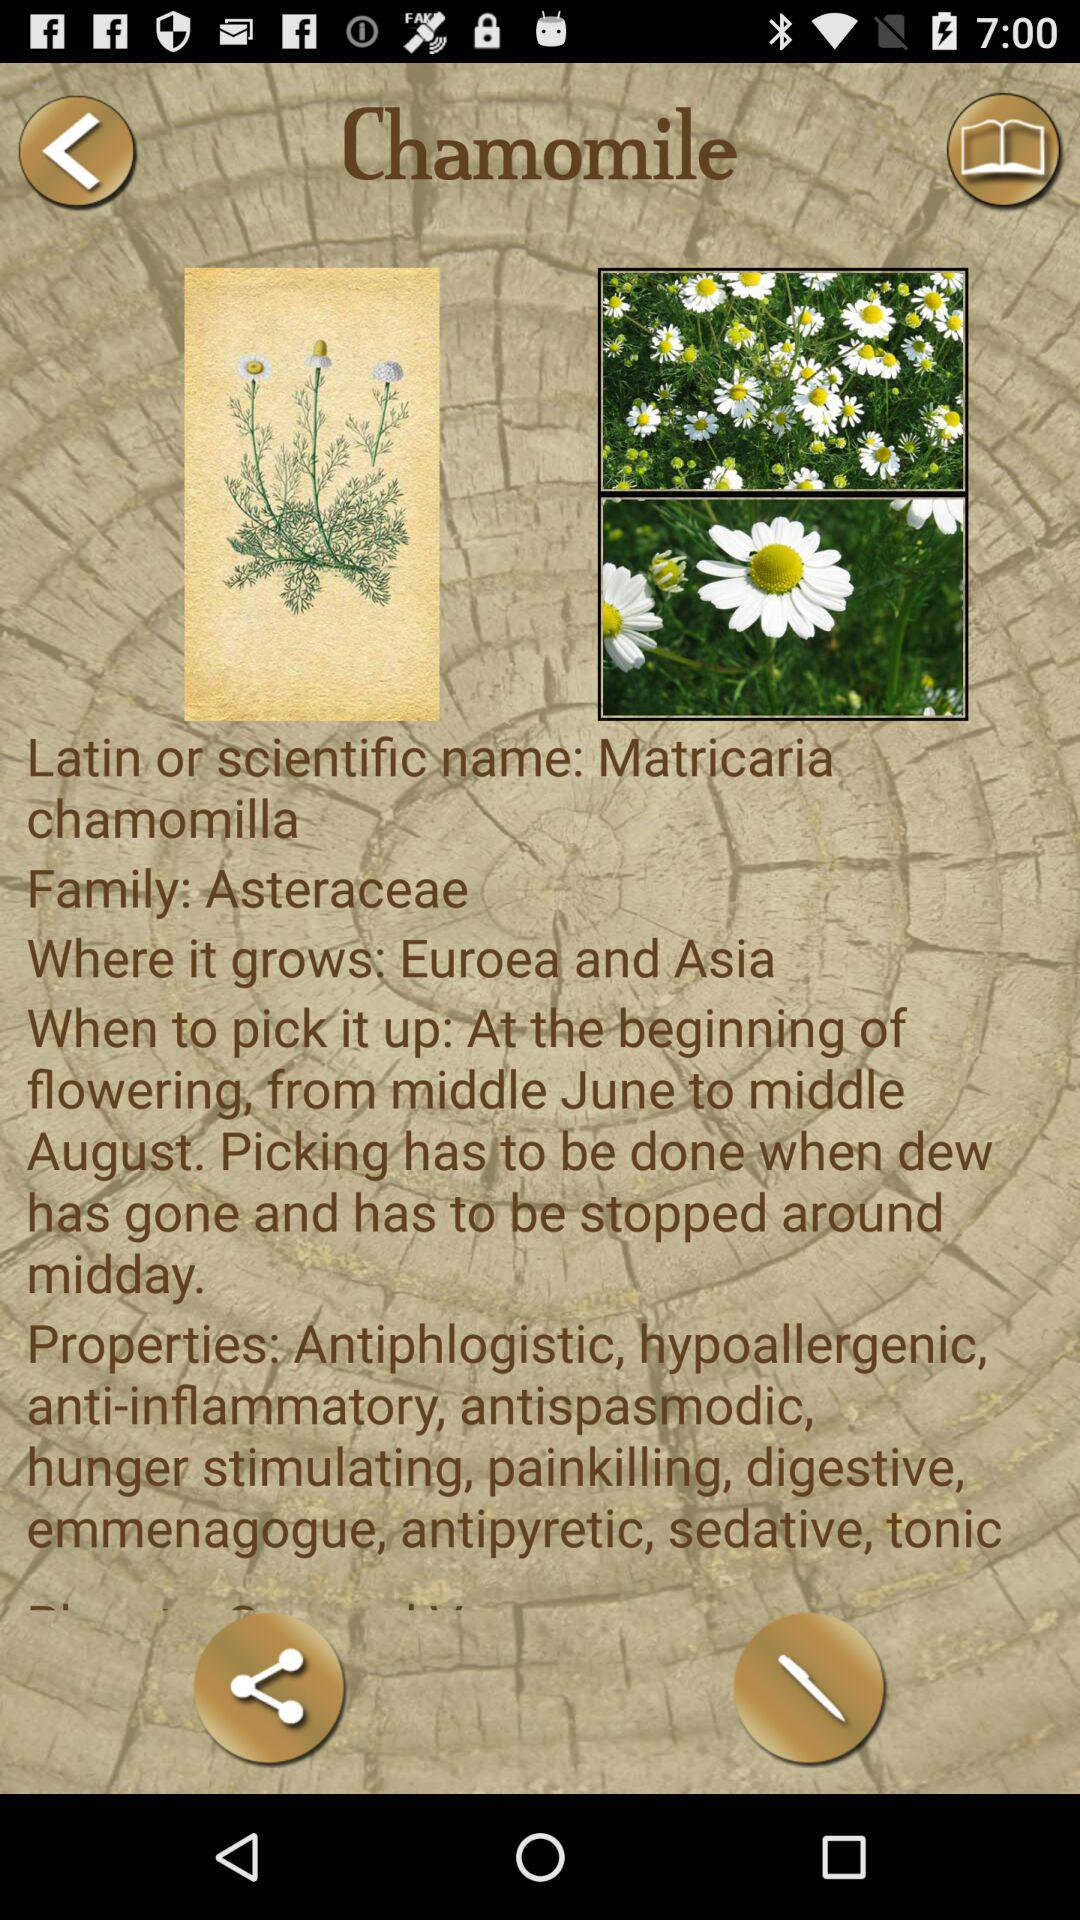What is the scientific name of chamomile? The scientific name of chamomile is Matricaria chamomilla. 